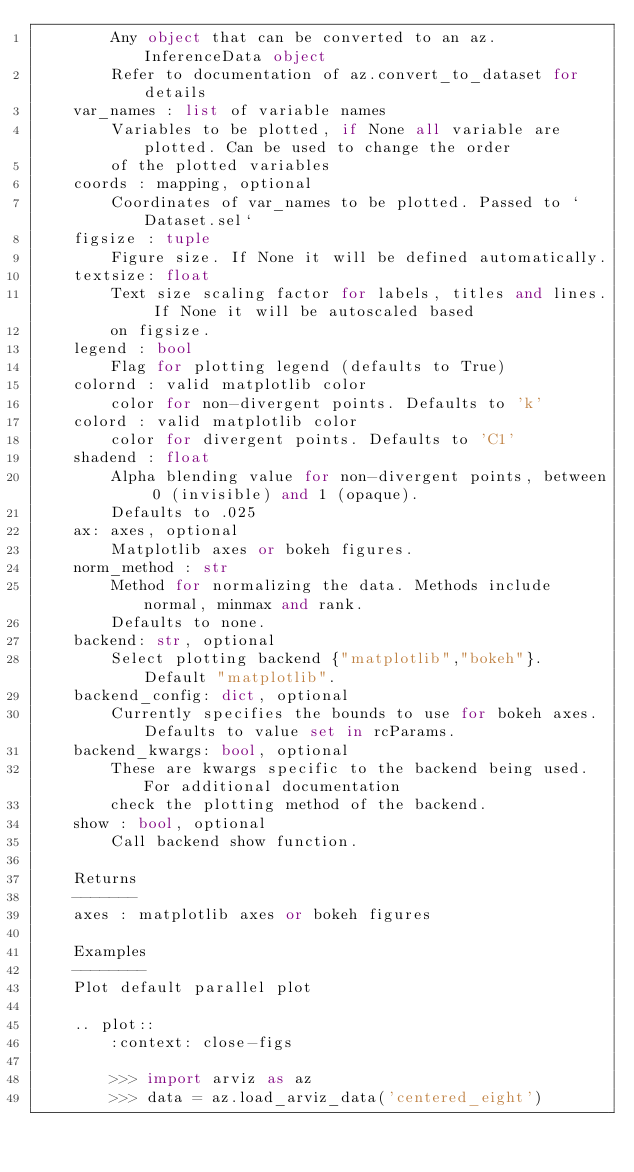Convert code to text. <code><loc_0><loc_0><loc_500><loc_500><_Python_>        Any object that can be converted to an az.InferenceData object
        Refer to documentation of az.convert_to_dataset for details
    var_names : list of variable names
        Variables to be plotted, if None all variable are plotted. Can be used to change the order
        of the plotted variables
    coords : mapping, optional
        Coordinates of var_names to be plotted. Passed to `Dataset.sel`
    figsize : tuple
        Figure size. If None it will be defined automatically.
    textsize: float
        Text size scaling factor for labels, titles and lines. If None it will be autoscaled based
        on figsize.
    legend : bool
        Flag for plotting legend (defaults to True)
    colornd : valid matplotlib color
        color for non-divergent points. Defaults to 'k'
    colord : valid matplotlib color
        color for divergent points. Defaults to 'C1'
    shadend : float
        Alpha blending value for non-divergent points, between 0 (invisible) and 1 (opaque).
        Defaults to .025
    ax: axes, optional
        Matplotlib axes or bokeh figures.
    norm_method : str
        Method for normalizing the data. Methods include normal, minmax and rank.
        Defaults to none.
    backend: str, optional
        Select plotting backend {"matplotlib","bokeh"}. Default "matplotlib".
    backend_config: dict, optional
        Currently specifies the bounds to use for bokeh axes. Defaults to value set in rcParams.
    backend_kwargs: bool, optional
        These are kwargs specific to the backend being used. For additional documentation
        check the plotting method of the backend.
    show : bool, optional
        Call backend show function.

    Returns
    -------
    axes : matplotlib axes or bokeh figures

    Examples
    --------
    Plot default parallel plot

    .. plot::
        :context: close-figs

        >>> import arviz as az
        >>> data = az.load_arviz_data('centered_eight')</code> 